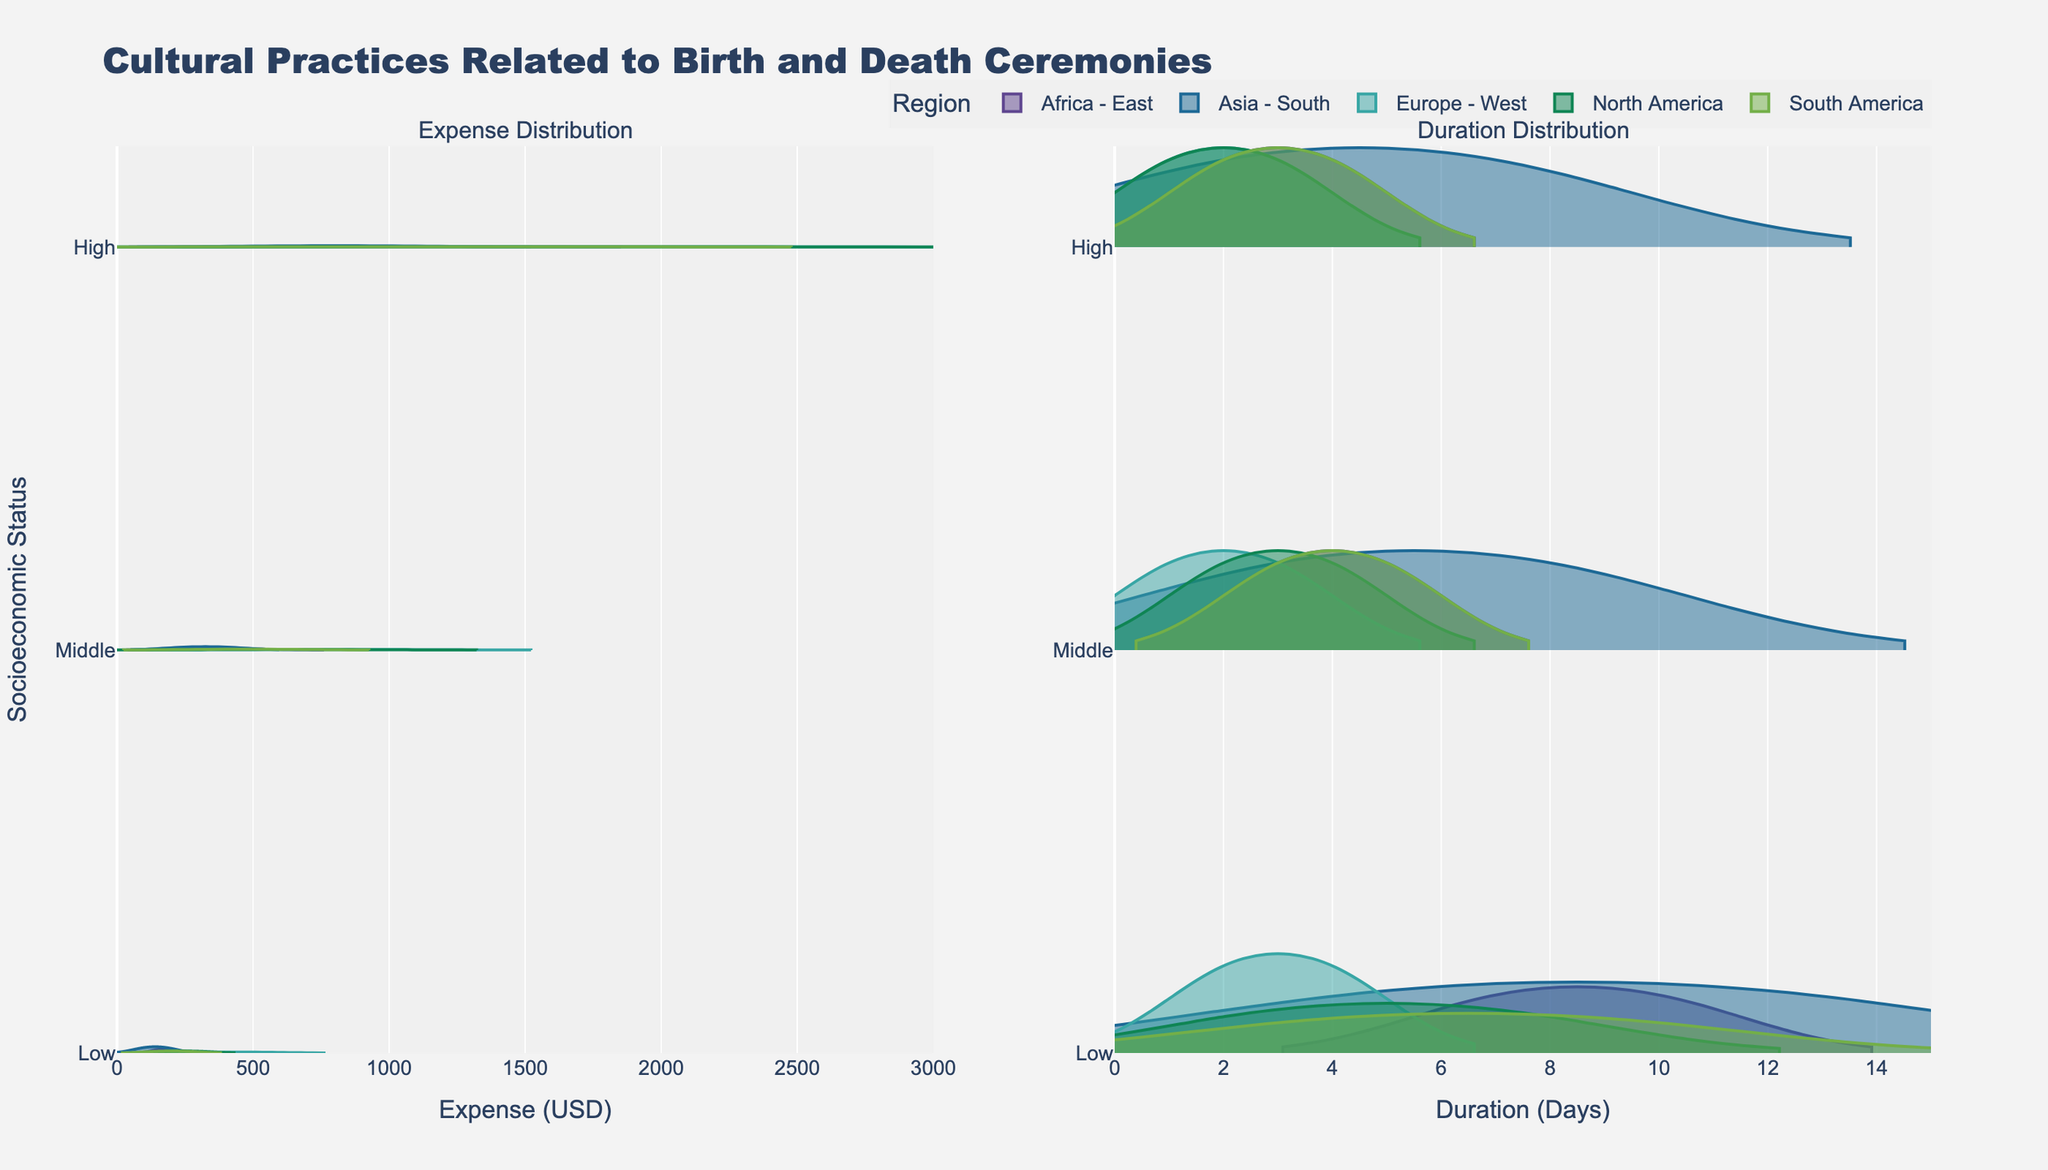What is the title of the figure? The title of the figure is usually displayed at the top and describes what the figure is about. Here, it's "Cultural Practices Related to Birth and Death Ceremonies."
Answer: Cultural Practices Related to Birth and Death Ceremonies Which region has the highest expense for high socioeconomic status during death ceremonies? Look at the violin plot on the left-hand side (Expense Distribution) and find the highest expense values for "High" socioeconomic status in the horizontal lines of each region.
Answer: Europe - West How many unique socioeconomic statuses are displayed in the figure? The socioeconomic statuses are represented by the y-axis labels on both violin plots. Count the unique labels along the y-axis.
Answer: 3 Which region shows the widest range in expenses for birth ceremonies? Identify the region with the widest spread in the Expense Distribution plot from low to high expenses specifically for birth ceremonies. Check the horizontal spread of the violins for birth across different regions.
Answer: Europe - West What is the general trend in expenses for birth ceremonies across different socioeconomic statuses? Observe the pattern of expenses for birth ceremonies in the Expense Distribution plot: typically, as socioeconomic status increases, expenses tend to decrease or increase. Compare the overall heights of the violins corresponding to low, middle, and high statuses.
Answer: Increases with higher socioeconomic status Which socioeconomic status has the longest duration of death ceremonies in East Africa? Check the Duration Distribution plot and look for the y-axis label "Africa - East". Compare the horizontal spread of violins in the "Death" category for different socioeconomic statuses.
Answer: Low What can be inferred about the duration of birth ceremonies in Europe compared to other regions for middle socioeconomic status? Compare the spread of the violin plots on the Duration Distribution plot for middle socioeconomic status in "Europe - West" with other regions. Assess whether durations are shorter or longer on average.
Answer: Shortest How do expenses for death ceremonies compare between South America and North America for high socioeconomic status? Compare the horizontal range and position of the violins representing high socioeconomic status for death ceremonies in South America and North America in the Expense Distribution plot.
Answer: Higher in North America Is there a region where the duration of death ceremonies is consistently among the longest across all socioeconomic statuses? Analyze the Duration Distribution plot to observe the horizontal spread of the violins for death ceremonies across all socioeconomic statuses in different regions. Identify which region consistently has longer durations.
Answer: Asia - South Which region exhibits the highest expenses for birth ceremonies regardless of socioeconomic status? Review the Expense Distribution plot and compare the expense spread for birth ceremonies across all socioeconomic statuses within each region. Identify the region with the highest expense spread overall.
Answer: Europe - West 